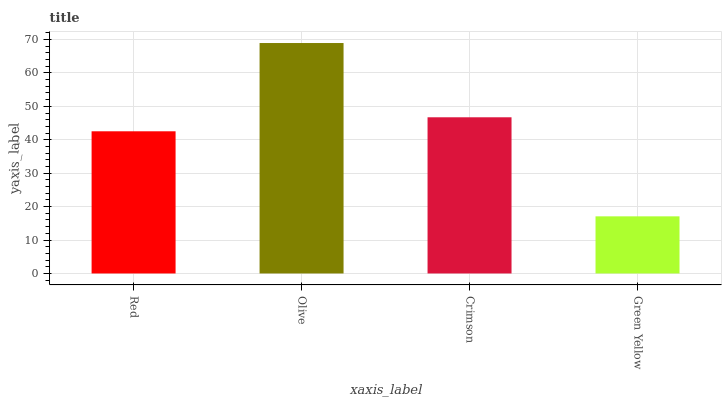Is Crimson the minimum?
Answer yes or no. No. Is Crimson the maximum?
Answer yes or no. No. Is Olive greater than Crimson?
Answer yes or no. Yes. Is Crimson less than Olive?
Answer yes or no. Yes. Is Crimson greater than Olive?
Answer yes or no. No. Is Olive less than Crimson?
Answer yes or no. No. Is Crimson the high median?
Answer yes or no. Yes. Is Red the low median?
Answer yes or no. Yes. Is Olive the high median?
Answer yes or no. No. Is Crimson the low median?
Answer yes or no. No. 